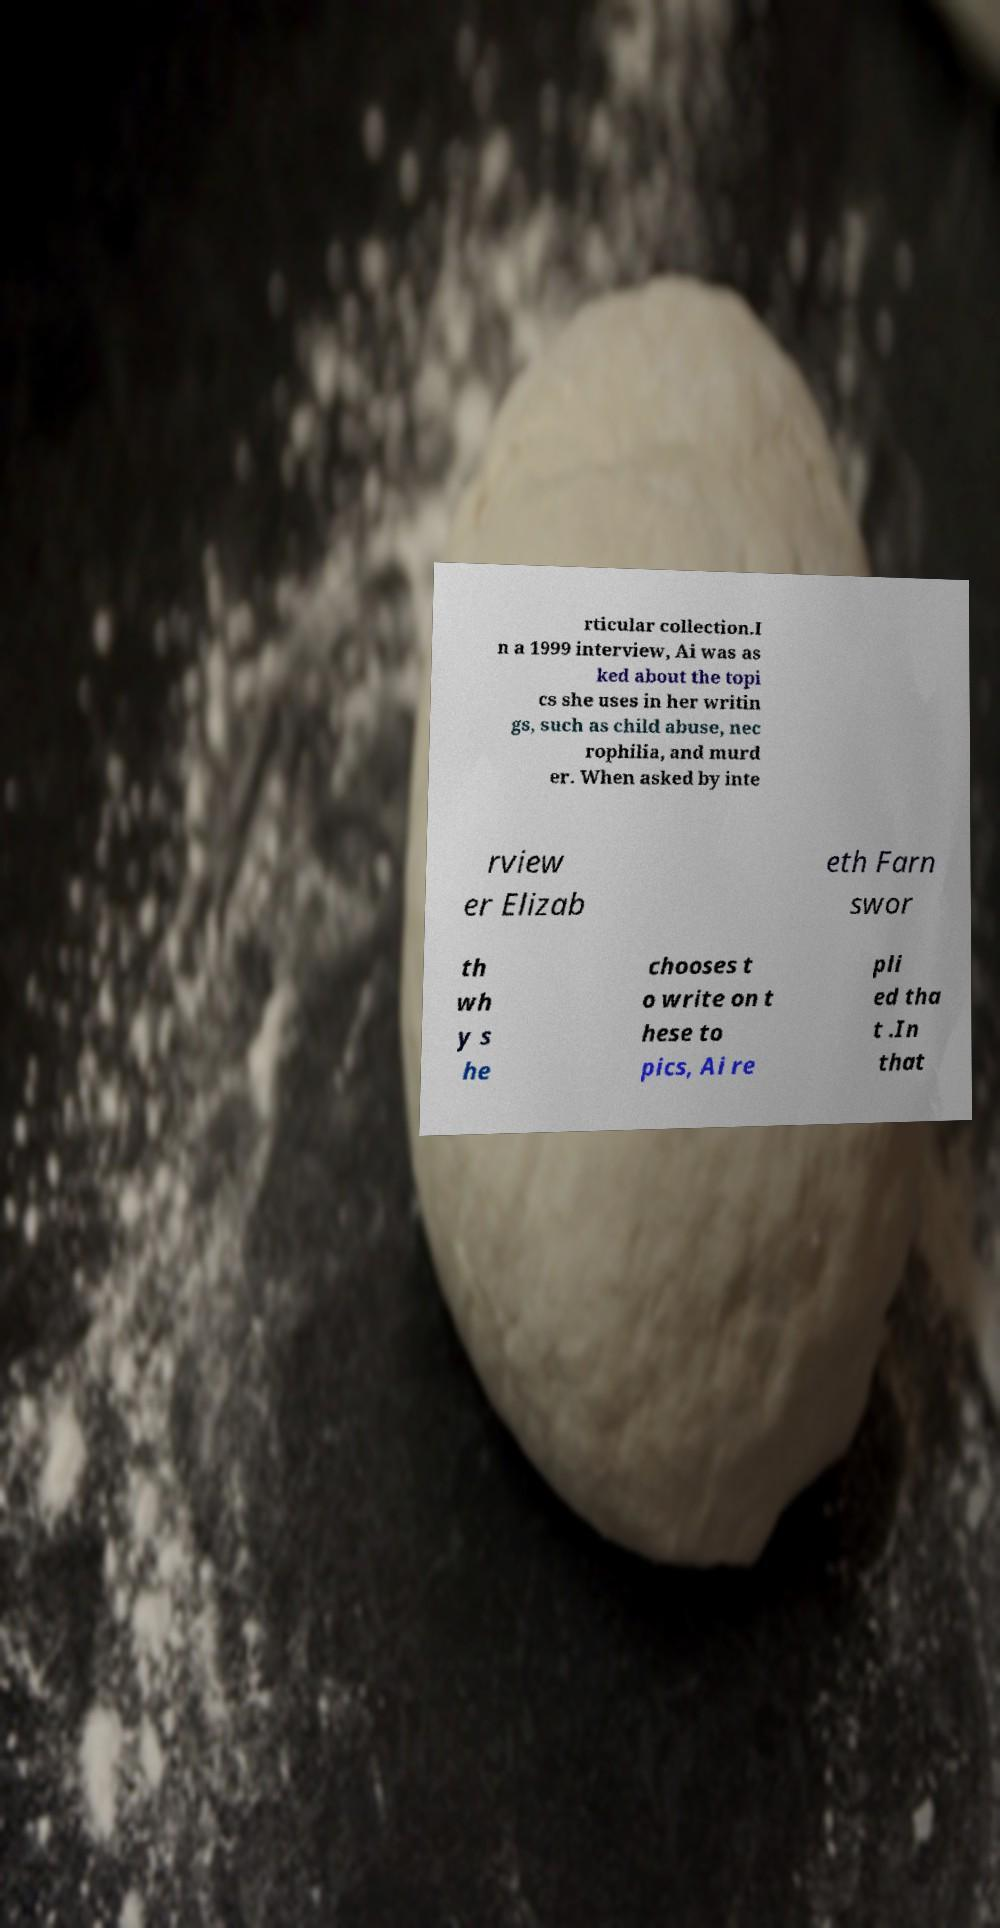For documentation purposes, I need the text within this image transcribed. Could you provide that? rticular collection.I n a 1999 interview, Ai was as ked about the topi cs she uses in her writin gs, such as child abuse, nec rophilia, and murd er. When asked by inte rview er Elizab eth Farn swor th wh y s he chooses t o write on t hese to pics, Ai re pli ed tha t .In that 